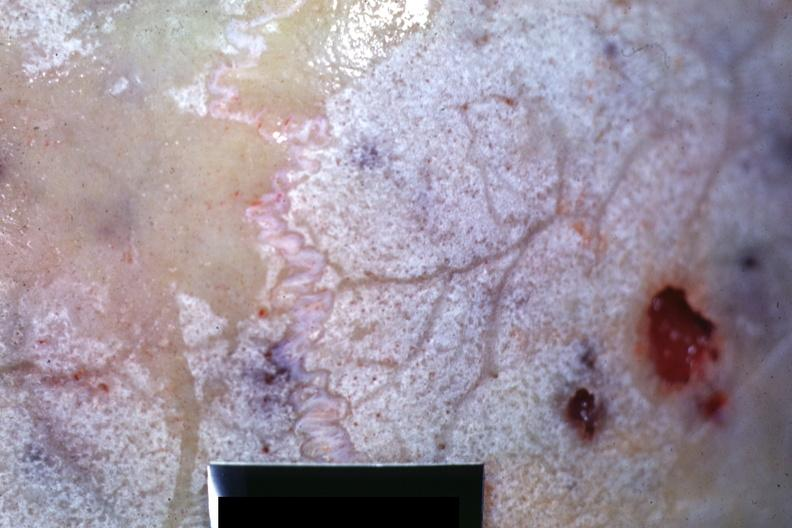what is present?
Answer the question using a single word or phrase. Multiple myeloma 